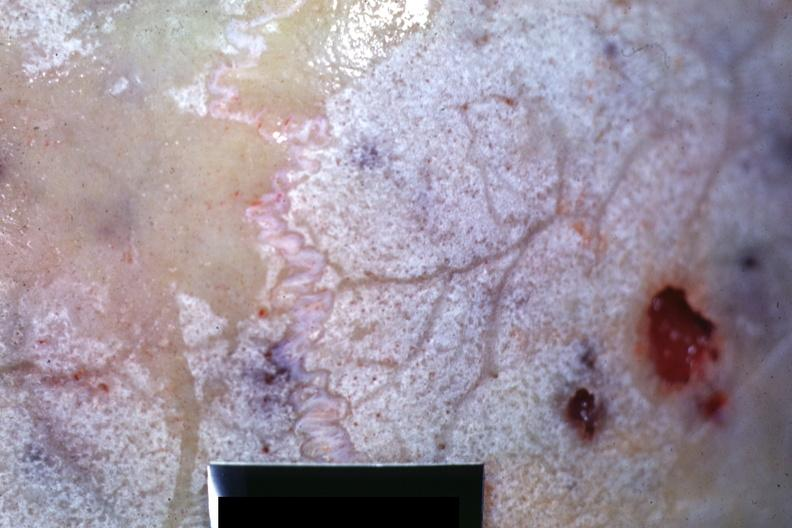what is present?
Answer the question using a single word or phrase. Multiple myeloma 